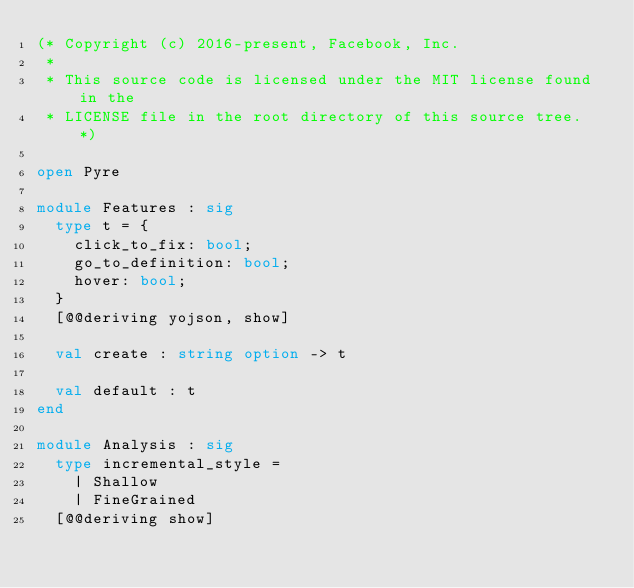Convert code to text. <code><loc_0><loc_0><loc_500><loc_500><_OCaml_>(* Copyright (c) 2016-present, Facebook, Inc.
 *
 * This source code is licensed under the MIT license found in the
 * LICENSE file in the root directory of this source tree. *)

open Pyre

module Features : sig
  type t = {
    click_to_fix: bool;
    go_to_definition: bool;
    hover: bool;
  }
  [@@deriving yojson, show]

  val create : string option -> t

  val default : t
end

module Analysis : sig
  type incremental_style =
    | Shallow
    | FineGrained
  [@@deriving show]
</code> 